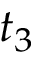Convert formula to latex. <formula><loc_0><loc_0><loc_500><loc_500>t _ { 3 }</formula> 